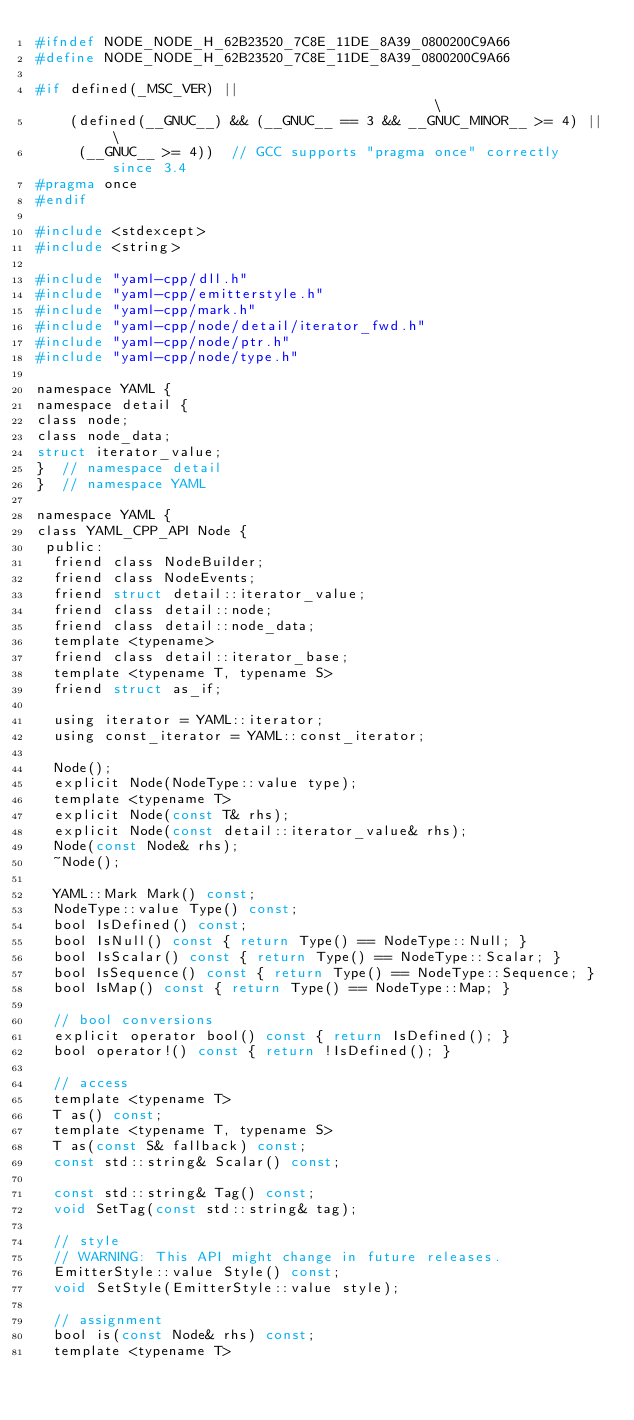Convert code to text. <code><loc_0><loc_0><loc_500><loc_500><_C_>#ifndef NODE_NODE_H_62B23520_7C8E_11DE_8A39_0800200C9A66
#define NODE_NODE_H_62B23520_7C8E_11DE_8A39_0800200C9A66

#if defined(_MSC_VER) ||                                            \
    (defined(__GNUC__) && (__GNUC__ == 3 && __GNUC_MINOR__ >= 4) || \
     (__GNUC__ >= 4))  // GCC supports "pragma once" correctly since 3.4
#pragma once
#endif

#include <stdexcept>
#include <string>

#include "yaml-cpp/dll.h"
#include "yaml-cpp/emitterstyle.h"
#include "yaml-cpp/mark.h"
#include "yaml-cpp/node/detail/iterator_fwd.h"
#include "yaml-cpp/node/ptr.h"
#include "yaml-cpp/node/type.h"

namespace YAML {
namespace detail {
class node;
class node_data;
struct iterator_value;
}  // namespace detail
}  // namespace YAML

namespace YAML {
class YAML_CPP_API Node {
 public:
  friend class NodeBuilder;
  friend class NodeEvents;
  friend struct detail::iterator_value;
  friend class detail::node;
  friend class detail::node_data;
  template <typename>
  friend class detail::iterator_base;
  template <typename T, typename S>
  friend struct as_if;

  using iterator = YAML::iterator;
  using const_iterator = YAML::const_iterator;

  Node();
  explicit Node(NodeType::value type);
  template <typename T>
  explicit Node(const T& rhs);
  explicit Node(const detail::iterator_value& rhs);
  Node(const Node& rhs);
  ~Node();

  YAML::Mark Mark() const;
  NodeType::value Type() const;
  bool IsDefined() const;
  bool IsNull() const { return Type() == NodeType::Null; }
  bool IsScalar() const { return Type() == NodeType::Scalar; }
  bool IsSequence() const { return Type() == NodeType::Sequence; }
  bool IsMap() const { return Type() == NodeType::Map; }

  // bool conversions
  explicit operator bool() const { return IsDefined(); }
  bool operator!() const { return !IsDefined(); }

  // access
  template <typename T>
  T as() const;
  template <typename T, typename S>
  T as(const S& fallback) const;
  const std::string& Scalar() const;

  const std::string& Tag() const;
  void SetTag(const std::string& tag);

  // style
  // WARNING: This API might change in future releases.
  EmitterStyle::value Style() const;
  void SetStyle(EmitterStyle::value style);

  // assignment
  bool is(const Node& rhs) const;
  template <typename T></code> 